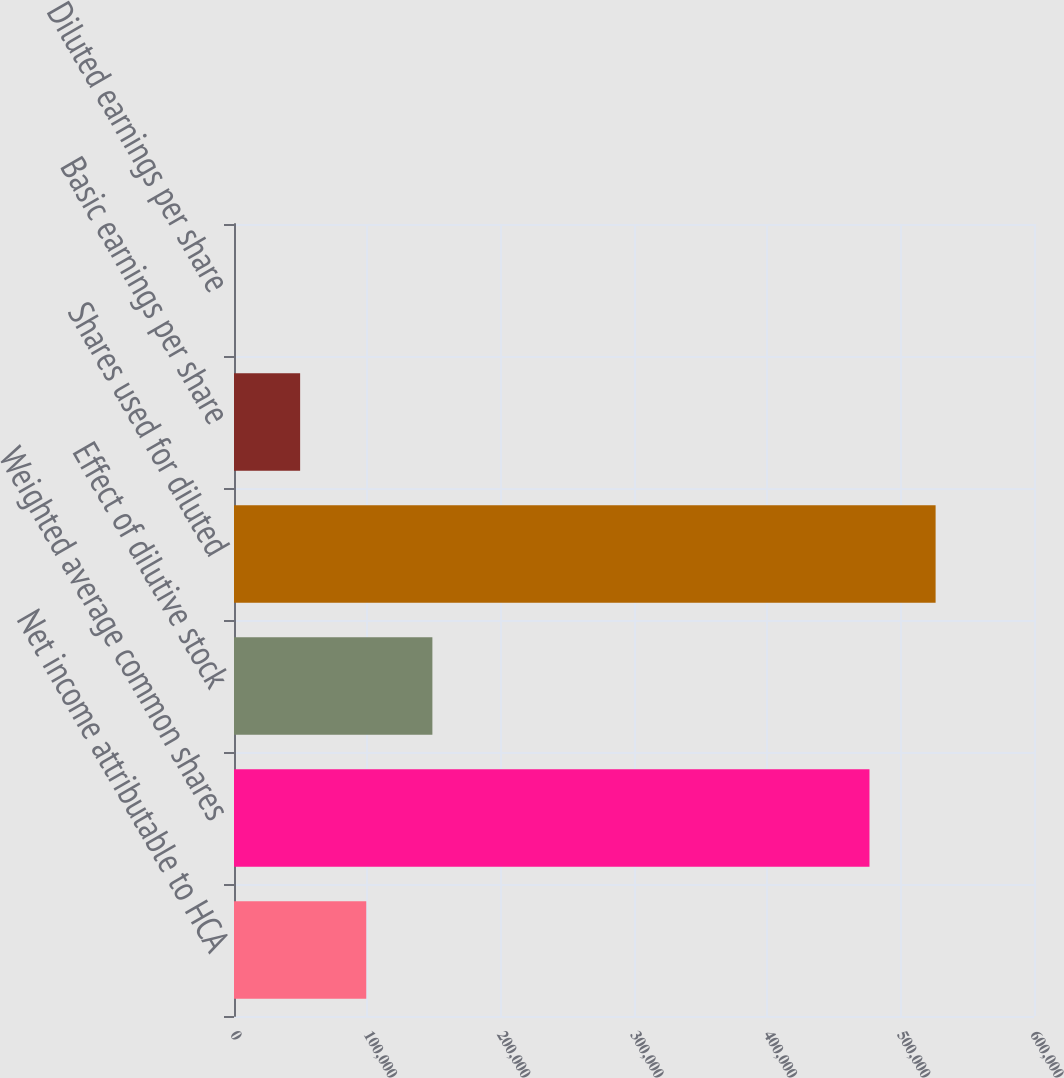Convert chart. <chart><loc_0><loc_0><loc_500><loc_500><bar_chart><fcel>Net income attributable to HCA<fcel>Weighted average common shares<fcel>Effect of dilutive stock<fcel>Shares used for diluted<fcel>Basic earnings per share<fcel>Diluted earnings per share<nl><fcel>99192.6<fcel>476609<fcel>148786<fcel>526203<fcel>49598.8<fcel>4.97<nl></chart> 